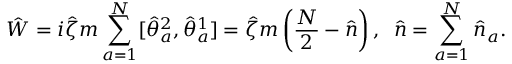<formula> <loc_0><loc_0><loc_500><loc_500>\hat { W } = i \hat { \zeta } m \sum _ { a = 1 } ^ { N } [ \hat { \theta } _ { a } ^ { 2 } , \hat { \theta } _ { a } ^ { 1 } ] = \hat { \zeta } m \left ( \frac { N } { 2 } - \hat { n } \right ) , \, \hat { n } = \sum _ { a = 1 } ^ { N } \hat { n } _ { a } .</formula> 